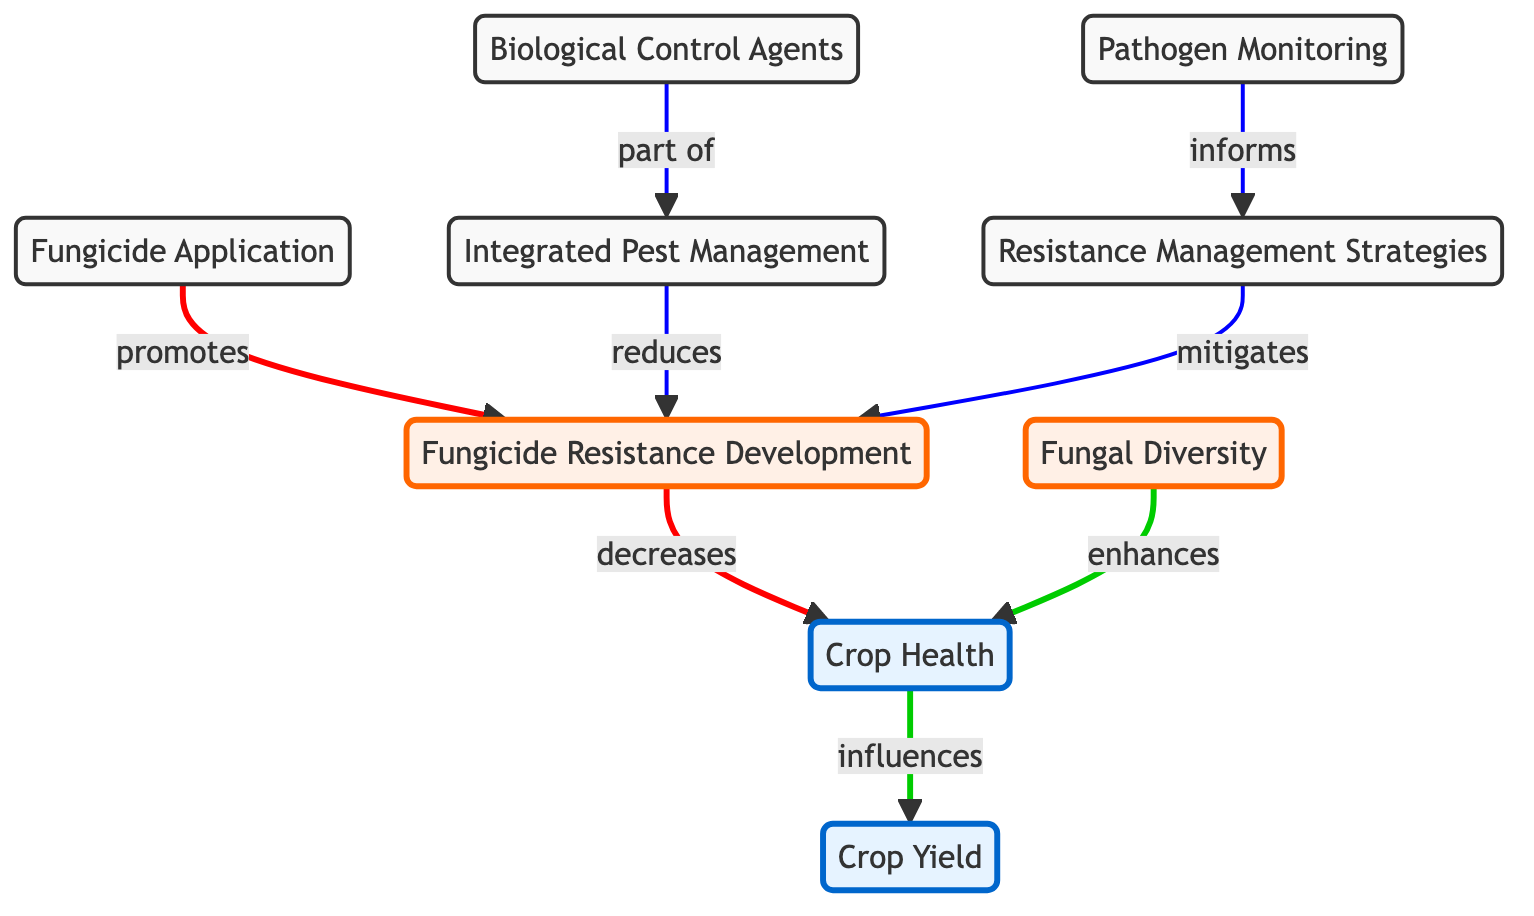What is the relationship between Fungicide Application and Fungicide Resistance Development? The diagram shows a directed edge from Fungicide Application to Fungicide Resistance Development, labeled "promotes". This indicates that Fungicide Application contributes to or encourages the development of Fungicide Resistance.
Answer: promotes How many nodes are in the diagram? The diagram lists a total of 9 nodes, which are Crop Yield, Fungal Diversity, Fungicide Application, Fungicide Resistance Development, Crop Health, Integrated Pest Management, Biological Control Agents, Pathogen Monitoring, and Resistance Management Strategies.
Answer: 9 What is the effect of Fungal Diversity on Crop Health? The diagram indicates a direct link from Fungal Diversity to Crop Health, shown as "enhances". This means that increased Fungal Diversity has a positive effect on Crop Health, improving its status or quality.
Answer: enhances Which strategy is part of Integrated Pest Management? According to the diagram, Biological Control Agents have a direct connection to Integrated Pest Management, identified by the label "part of". This means that Biological Control Agents are included within the broader strategy of Integrated Pest Management.
Answer: Biological Control Agents How do Resistance Management Strategies impact Fungicide Resistance Development? The diagram reveals a directed edge from Resistance Management Strategies to Fungicide Resistance Development, noted as "mitigates". This implies that implementing Resistance Management Strategies helps to reduce or lessen the progression of Fungicide Resistance Development.
Answer: mitigates 